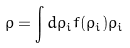<formula> <loc_0><loc_0><loc_500><loc_500>\rho = \int d \rho _ { i } f ( \rho _ { i } ) \rho _ { i }</formula> 